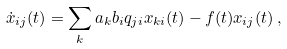Convert formula to latex. <formula><loc_0><loc_0><loc_500><loc_500>\dot { x } _ { i j } ( t ) = \sum _ { k } a _ { k } b _ { i } q _ { j i } x _ { k i } ( t ) - f ( t ) x _ { i j } ( t ) \, ,</formula> 